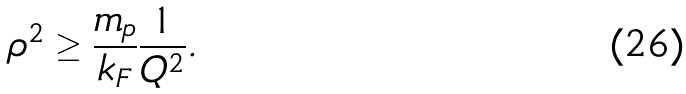Convert formula to latex. <formula><loc_0><loc_0><loc_500><loc_500>\rho ^ { 2 } \geq \frac { m _ { p } } { k _ { F } } \frac { 1 } { Q ^ { 2 } } .</formula> 